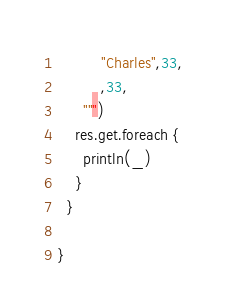Convert code to text. <code><loc_0><loc_0><loc_500><loc_500><_Scala_>          "Charles",33,
          ,33,
      """)
    res.get.foreach {
      println(_)
    }
  }

}</code> 